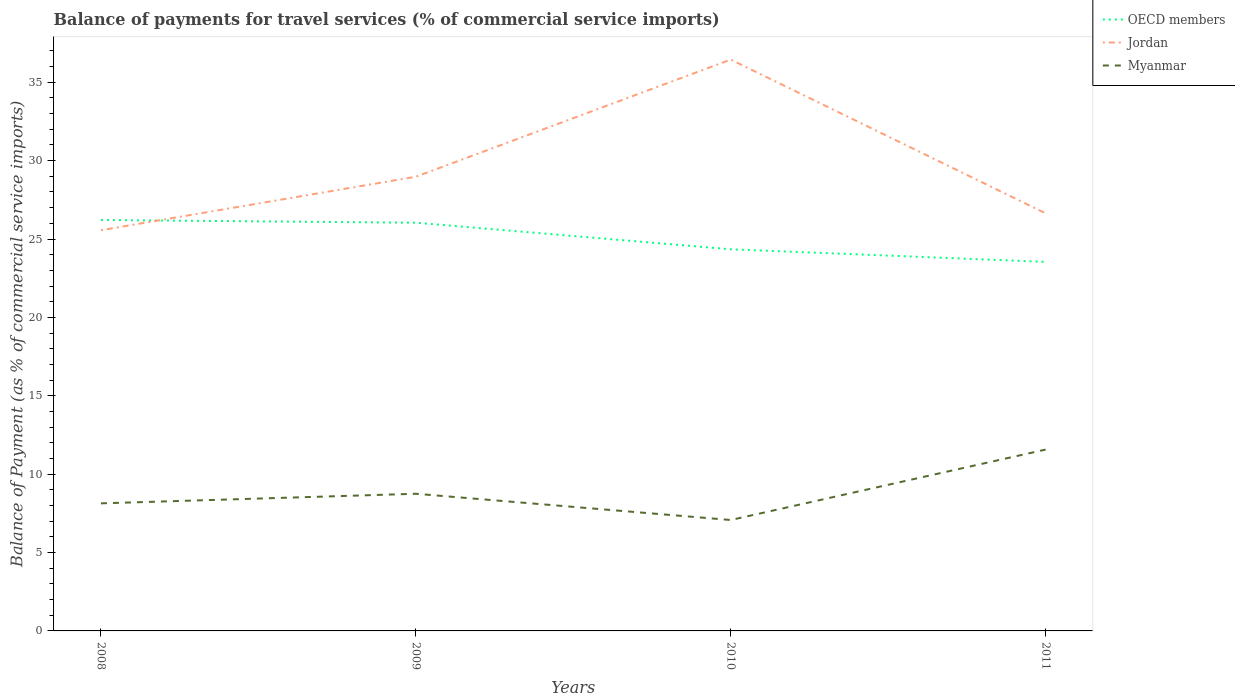How many different coloured lines are there?
Your response must be concise. 3. Does the line corresponding to Myanmar intersect with the line corresponding to Jordan?
Offer a terse response. No. Is the number of lines equal to the number of legend labels?
Make the answer very short. Yes. Across all years, what is the maximum balance of payments for travel services in Jordan?
Make the answer very short. 25.56. In which year was the balance of payments for travel services in Jordan maximum?
Provide a succinct answer. 2008. What is the total balance of payments for travel services in Myanmar in the graph?
Provide a succinct answer. -4.49. What is the difference between the highest and the second highest balance of payments for travel services in OECD members?
Your answer should be very brief. 2.67. What is the difference between two consecutive major ticks on the Y-axis?
Your response must be concise. 5. How are the legend labels stacked?
Your answer should be very brief. Vertical. What is the title of the graph?
Provide a succinct answer. Balance of payments for travel services (% of commercial service imports). What is the label or title of the X-axis?
Offer a terse response. Years. What is the label or title of the Y-axis?
Your answer should be very brief. Balance of Payment (as % of commercial service imports). What is the Balance of Payment (as % of commercial service imports) in OECD members in 2008?
Offer a terse response. 26.21. What is the Balance of Payment (as % of commercial service imports) of Jordan in 2008?
Ensure brevity in your answer.  25.56. What is the Balance of Payment (as % of commercial service imports) in Myanmar in 2008?
Your response must be concise. 8.14. What is the Balance of Payment (as % of commercial service imports) in OECD members in 2009?
Provide a short and direct response. 26.04. What is the Balance of Payment (as % of commercial service imports) of Jordan in 2009?
Your response must be concise. 28.97. What is the Balance of Payment (as % of commercial service imports) of Myanmar in 2009?
Give a very brief answer. 8.75. What is the Balance of Payment (as % of commercial service imports) of OECD members in 2010?
Your answer should be very brief. 24.34. What is the Balance of Payment (as % of commercial service imports) of Jordan in 2010?
Provide a short and direct response. 36.44. What is the Balance of Payment (as % of commercial service imports) of Myanmar in 2010?
Give a very brief answer. 7.08. What is the Balance of Payment (as % of commercial service imports) of OECD members in 2011?
Provide a short and direct response. 23.54. What is the Balance of Payment (as % of commercial service imports) of Jordan in 2011?
Make the answer very short. 26.64. What is the Balance of Payment (as % of commercial service imports) in Myanmar in 2011?
Offer a very short reply. 11.57. Across all years, what is the maximum Balance of Payment (as % of commercial service imports) in OECD members?
Your response must be concise. 26.21. Across all years, what is the maximum Balance of Payment (as % of commercial service imports) in Jordan?
Offer a very short reply. 36.44. Across all years, what is the maximum Balance of Payment (as % of commercial service imports) of Myanmar?
Provide a succinct answer. 11.57. Across all years, what is the minimum Balance of Payment (as % of commercial service imports) of OECD members?
Make the answer very short. 23.54. Across all years, what is the minimum Balance of Payment (as % of commercial service imports) in Jordan?
Your response must be concise. 25.56. Across all years, what is the minimum Balance of Payment (as % of commercial service imports) of Myanmar?
Keep it short and to the point. 7.08. What is the total Balance of Payment (as % of commercial service imports) in OECD members in the graph?
Offer a terse response. 100.14. What is the total Balance of Payment (as % of commercial service imports) in Jordan in the graph?
Make the answer very short. 117.62. What is the total Balance of Payment (as % of commercial service imports) in Myanmar in the graph?
Offer a very short reply. 35.53. What is the difference between the Balance of Payment (as % of commercial service imports) of OECD members in 2008 and that in 2009?
Your answer should be very brief. 0.17. What is the difference between the Balance of Payment (as % of commercial service imports) in Jordan in 2008 and that in 2009?
Keep it short and to the point. -3.41. What is the difference between the Balance of Payment (as % of commercial service imports) in Myanmar in 2008 and that in 2009?
Your response must be concise. -0.61. What is the difference between the Balance of Payment (as % of commercial service imports) in OECD members in 2008 and that in 2010?
Your answer should be very brief. 1.87. What is the difference between the Balance of Payment (as % of commercial service imports) in Jordan in 2008 and that in 2010?
Provide a short and direct response. -10.88. What is the difference between the Balance of Payment (as % of commercial service imports) in Myanmar in 2008 and that in 2010?
Ensure brevity in your answer.  1.06. What is the difference between the Balance of Payment (as % of commercial service imports) in OECD members in 2008 and that in 2011?
Offer a very short reply. 2.67. What is the difference between the Balance of Payment (as % of commercial service imports) in Jordan in 2008 and that in 2011?
Your response must be concise. -1.08. What is the difference between the Balance of Payment (as % of commercial service imports) of Myanmar in 2008 and that in 2011?
Provide a short and direct response. -3.43. What is the difference between the Balance of Payment (as % of commercial service imports) of OECD members in 2009 and that in 2010?
Your response must be concise. 1.7. What is the difference between the Balance of Payment (as % of commercial service imports) of Jordan in 2009 and that in 2010?
Give a very brief answer. -7.47. What is the difference between the Balance of Payment (as % of commercial service imports) of Myanmar in 2009 and that in 2010?
Ensure brevity in your answer.  1.67. What is the difference between the Balance of Payment (as % of commercial service imports) of OECD members in 2009 and that in 2011?
Give a very brief answer. 2.5. What is the difference between the Balance of Payment (as % of commercial service imports) of Jordan in 2009 and that in 2011?
Give a very brief answer. 2.33. What is the difference between the Balance of Payment (as % of commercial service imports) in Myanmar in 2009 and that in 2011?
Provide a succinct answer. -2.82. What is the difference between the Balance of Payment (as % of commercial service imports) in OECD members in 2010 and that in 2011?
Give a very brief answer. 0.8. What is the difference between the Balance of Payment (as % of commercial service imports) of Jordan in 2010 and that in 2011?
Offer a terse response. 9.81. What is the difference between the Balance of Payment (as % of commercial service imports) of Myanmar in 2010 and that in 2011?
Offer a very short reply. -4.49. What is the difference between the Balance of Payment (as % of commercial service imports) of OECD members in 2008 and the Balance of Payment (as % of commercial service imports) of Jordan in 2009?
Give a very brief answer. -2.76. What is the difference between the Balance of Payment (as % of commercial service imports) of OECD members in 2008 and the Balance of Payment (as % of commercial service imports) of Myanmar in 2009?
Offer a terse response. 17.46. What is the difference between the Balance of Payment (as % of commercial service imports) of Jordan in 2008 and the Balance of Payment (as % of commercial service imports) of Myanmar in 2009?
Your answer should be very brief. 16.81. What is the difference between the Balance of Payment (as % of commercial service imports) in OECD members in 2008 and the Balance of Payment (as % of commercial service imports) in Jordan in 2010?
Your answer should be compact. -10.23. What is the difference between the Balance of Payment (as % of commercial service imports) of OECD members in 2008 and the Balance of Payment (as % of commercial service imports) of Myanmar in 2010?
Offer a very short reply. 19.14. What is the difference between the Balance of Payment (as % of commercial service imports) of Jordan in 2008 and the Balance of Payment (as % of commercial service imports) of Myanmar in 2010?
Your answer should be compact. 18.49. What is the difference between the Balance of Payment (as % of commercial service imports) in OECD members in 2008 and the Balance of Payment (as % of commercial service imports) in Jordan in 2011?
Your answer should be compact. -0.43. What is the difference between the Balance of Payment (as % of commercial service imports) in OECD members in 2008 and the Balance of Payment (as % of commercial service imports) in Myanmar in 2011?
Provide a succinct answer. 14.65. What is the difference between the Balance of Payment (as % of commercial service imports) in Jordan in 2008 and the Balance of Payment (as % of commercial service imports) in Myanmar in 2011?
Offer a very short reply. 13.99. What is the difference between the Balance of Payment (as % of commercial service imports) in OECD members in 2009 and the Balance of Payment (as % of commercial service imports) in Jordan in 2010?
Ensure brevity in your answer.  -10.4. What is the difference between the Balance of Payment (as % of commercial service imports) in OECD members in 2009 and the Balance of Payment (as % of commercial service imports) in Myanmar in 2010?
Keep it short and to the point. 18.96. What is the difference between the Balance of Payment (as % of commercial service imports) of Jordan in 2009 and the Balance of Payment (as % of commercial service imports) of Myanmar in 2010?
Provide a succinct answer. 21.9. What is the difference between the Balance of Payment (as % of commercial service imports) of OECD members in 2009 and the Balance of Payment (as % of commercial service imports) of Jordan in 2011?
Ensure brevity in your answer.  -0.6. What is the difference between the Balance of Payment (as % of commercial service imports) of OECD members in 2009 and the Balance of Payment (as % of commercial service imports) of Myanmar in 2011?
Your response must be concise. 14.47. What is the difference between the Balance of Payment (as % of commercial service imports) of Jordan in 2009 and the Balance of Payment (as % of commercial service imports) of Myanmar in 2011?
Provide a short and direct response. 17.41. What is the difference between the Balance of Payment (as % of commercial service imports) in OECD members in 2010 and the Balance of Payment (as % of commercial service imports) in Jordan in 2011?
Offer a terse response. -2.29. What is the difference between the Balance of Payment (as % of commercial service imports) of OECD members in 2010 and the Balance of Payment (as % of commercial service imports) of Myanmar in 2011?
Your answer should be very brief. 12.78. What is the difference between the Balance of Payment (as % of commercial service imports) of Jordan in 2010 and the Balance of Payment (as % of commercial service imports) of Myanmar in 2011?
Ensure brevity in your answer.  24.88. What is the average Balance of Payment (as % of commercial service imports) of OECD members per year?
Your answer should be very brief. 25.03. What is the average Balance of Payment (as % of commercial service imports) in Jordan per year?
Your answer should be compact. 29.4. What is the average Balance of Payment (as % of commercial service imports) in Myanmar per year?
Provide a succinct answer. 8.88. In the year 2008, what is the difference between the Balance of Payment (as % of commercial service imports) of OECD members and Balance of Payment (as % of commercial service imports) of Jordan?
Keep it short and to the point. 0.65. In the year 2008, what is the difference between the Balance of Payment (as % of commercial service imports) in OECD members and Balance of Payment (as % of commercial service imports) in Myanmar?
Ensure brevity in your answer.  18.08. In the year 2008, what is the difference between the Balance of Payment (as % of commercial service imports) in Jordan and Balance of Payment (as % of commercial service imports) in Myanmar?
Your response must be concise. 17.42. In the year 2009, what is the difference between the Balance of Payment (as % of commercial service imports) in OECD members and Balance of Payment (as % of commercial service imports) in Jordan?
Offer a very short reply. -2.93. In the year 2009, what is the difference between the Balance of Payment (as % of commercial service imports) of OECD members and Balance of Payment (as % of commercial service imports) of Myanmar?
Ensure brevity in your answer.  17.29. In the year 2009, what is the difference between the Balance of Payment (as % of commercial service imports) of Jordan and Balance of Payment (as % of commercial service imports) of Myanmar?
Give a very brief answer. 20.22. In the year 2010, what is the difference between the Balance of Payment (as % of commercial service imports) in OECD members and Balance of Payment (as % of commercial service imports) in Jordan?
Your response must be concise. -12.1. In the year 2010, what is the difference between the Balance of Payment (as % of commercial service imports) in OECD members and Balance of Payment (as % of commercial service imports) in Myanmar?
Offer a very short reply. 17.27. In the year 2010, what is the difference between the Balance of Payment (as % of commercial service imports) of Jordan and Balance of Payment (as % of commercial service imports) of Myanmar?
Keep it short and to the point. 29.37. In the year 2011, what is the difference between the Balance of Payment (as % of commercial service imports) in OECD members and Balance of Payment (as % of commercial service imports) in Jordan?
Provide a succinct answer. -3.1. In the year 2011, what is the difference between the Balance of Payment (as % of commercial service imports) in OECD members and Balance of Payment (as % of commercial service imports) in Myanmar?
Your response must be concise. 11.97. In the year 2011, what is the difference between the Balance of Payment (as % of commercial service imports) of Jordan and Balance of Payment (as % of commercial service imports) of Myanmar?
Make the answer very short. 15.07. What is the ratio of the Balance of Payment (as % of commercial service imports) of OECD members in 2008 to that in 2009?
Your response must be concise. 1.01. What is the ratio of the Balance of Payment (as % of commercial service imports) of Jordan in 2008 to that in 2009?
Offer a very short reply. 0.88. What is the ratio of the Balance of Payment (as % of commercial service imports) in Myanmar in 2008 to that in 2009?
Your answer should be very brief. 0.93. What is the ratio of the Balance of Payment (as % of commercial service imports) in OECD members in 2008 to that in 2010?
Your answer should be very brief. 1.08. What is the ratio of the Balance of Payment (as % of commercial service imports) in Jordan in 2008 to that in 2010?
Give a very brief answer. 0.7. What is the ratio of the Balance of Payment (as % of commercial service imports) of Myanmar in 2008 to that in 2010?
Your answer should be very brief. 1.15. What is the ratio of the Balance of Payment (as % of commercial service imports) in OECD members in 2008 to that in 2011?
Keep it short and to the point. 1.11. What is the ratio of the Balance of Payment (as % of commercial service imports) in Jordan in 2008 to that in 2011?
Make the answer very short. 0.96. What is the ratio of the Balance of Payment (as % of commercial service imports) in Myanmar in 2008 to that in 2011?
Offer a terse response. 0.7. What is the ratio of the Balance of Payment (as % of commercial service imports) of OECD members in 2009 to that in 2010?
Offer a very short reply. 1.07. What is the ratio of the Balance of Payment (as % of commercial service imports) of Jordan in 2009 to that in 2010?
Offer a terse response. 0.8. What is the ratio of the Balance of Payment (as % of commercial service imports) in Myanmar in 2009 to that in 2010?
Provide a succinct answer. 1.24. What is the ratio of the Balance of Payment (as % of commercial service imports) of OECD members in 2009 to that in 2011?
Give a very brief answer. 1.11. What is the ratio of the Balance of Payment (as % of commercial service imports) of Jordan in 2009 to that in 2011?
Keep it short and to the point. 1.09. What is the ratio of the Balance of Payment (as % of commercial service imports) in Myanmar in 2009 to that in 2011?
Your answer should be compact. 0.76. What is the ratio of the Balance of Payment (as % of commercial service imports) in OECD members in 2010 to that in 2011?
Ensure brevity in your answer.  1.03. What is the ratio of the Balance of Payment (as % of commercial service imports) in Jordan in 2010 to that in 2011?
Provide a succinct answer. 1.37. What is the ratio of the Balance of Payment (as % of commercial service imports) of Myanmar in 2010 to that in 2011?
Your answer should be compact. 0.61. What is the difference between the highest and the second highest Balance of Payment (as % of commercial service imports) of OECD members?
Your answer should be compact. 0.17. What is the difference between the highest and the second highest Balance of Payment (as % of commercial service imports) in Jordan?
Ensure brevity in your answer.  7.47. What is the difference between the highest and the second highest Balance of Payment (as % of commercial service imports) of Myanmar?
Your response must be concise. 2.82. What is the difference between the highest and the lowest Balance of Payment (as % of commercial service imports) of OECD members?
Keep it short and to the point. 2.67. What is the difference between the highest and the lowest Balance of Payment (as % of commercial service imports) in Jordan?
Give a very brief answer. 10.88. What is the difference between the highest and the lowest Balance of Payment (as % of commercial service imports) in Myanmar?
Provide a succinct answer. 4.49. 